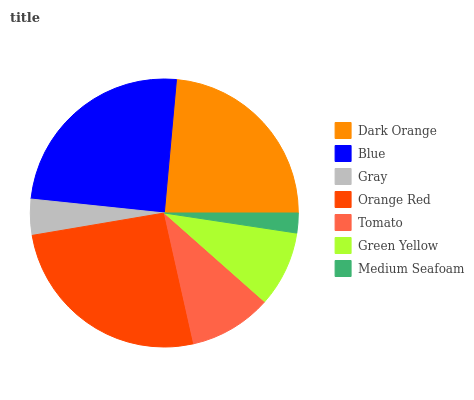Is Medium Seafoam the minimum?
Answer yes or no. Yes. Is Orange Red the maximum?
Answer yes or no. Yes. Is Blue the minimum?
Answer yes or no. No. Is Blue the maximum?
Answer yes or no. No. Is Blue greater than Dark Orange?
Answer yes or no. Yes. Is Dark Orange less than Blue?
Answer yes or no. Yes. Is Dark Orange greater than Blue?
Answer yes or no. No. Is Blue less than Dark Orange?
Answer yes or no. No. Is Tomato the high median?
Answer yes or no. Yes. Is Tomato the low median?
Answer yes or no. Yes. Is Dark Orange the high median?
Answer yes or no. No. Is Blue the low median?
Answer yes or no. No. 